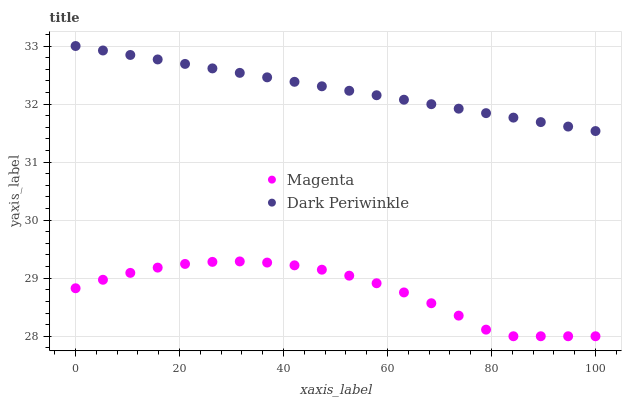Does Magenta have the minimum area under the curve?
Answer yes or no. Yes. Does Dark Periwinkle have the maximum area under the curve?
Answer yes or no. Yes. Does Dark Periwinkle have the minimum area under the curve?
Answer yes or no. No. Is Dark Periwinkle the smoothest?
Answer yes or no. Yes. Is Magenta the roughest?
Answer yes or no. Yes. Is Dark Periwinkle the roughest?
Answer yes or no. No. Does Magenta have the lowest value?
Answer yes or no. Yes. Does Dark Periwinkle have the lowest value?
Answer yes or no. No. Does Dark Periwinkle have the highest value?
Answer yes or no. Yes. Is Magenta less than Dark Periwinkle?
Answer yes or no. Yes. Is Dark Periwinkle greater than Magenta?
Answer yes or no. Yes. Does Magenta intersect Dark Periwinkle?
Answer yes or no. No. 